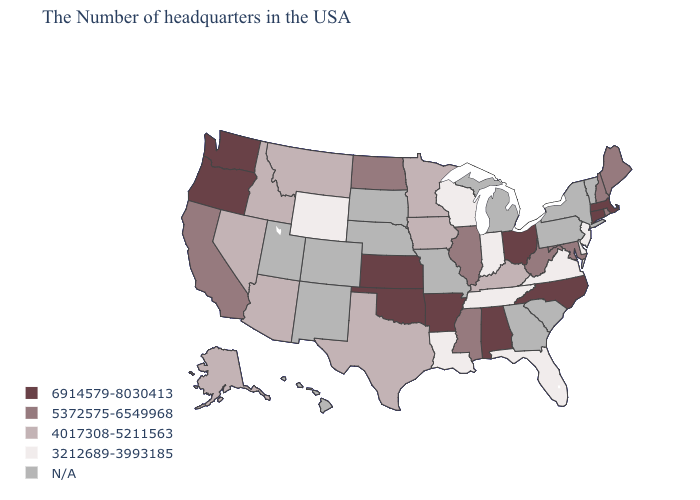What is the value of Arizona?
Be succinct. 4017308-5211563. Among the states that border Louisiana , does Arkansas have the highest value?
Quick response, please. Yes. Does Tennessee have the lowest value in the USA?
Short answer required. Yes. How many symbols are there in the legend?
Be succinct. 5. Among the states that border New Jersey , which have the highest value?
Concise answer only. Delaware. Name the states that have a value in the range 3212689-3993185?
Give a very brief answer. New Jersey, Delaware, Virginia, Florida, Indiana, Tennessee, Wisconsin, Louisiana, Wyoming. Does Wisconsin have the lowest value in the USA?
Keep it brief. Yes. Name the states that have a value in the range 6914579-8030413?
Write a very short answer. Massachusetts, Connecticut, North Carolina, Ohio, Alabama, Arkansas, Kansas, Oklahoma, Washington, Oregon. Which states have the highest value in the USA?
Keep it brief. Massachusetts, Connecticut, North Carolina, Ohio, Alabama, Arkansas, Kansas, Oklahoma, Washington, Oregon. What is the highest value in states that border Tennessee?
Be succinct. 6914579-8030413. How many symbols are there in the legend?
Give a very brief answer. 5. Name the states that have a value in the range 4017308-5211563?
Keep it brief. Kentucky, Minnesota, Iowa, Texas, Montana, Arizona, Idaho, Nevada, Alaska. Name the states that have a value in the range 3212689-3993185?
Quick response, please. New Jersey, Delaware, Virginia, Florida, Indiana, Tennessee, Wisconsin, Louisiana, Wyoming. Does Indiana have the lowest value in the MidWest?
Short answer required. Yes. 